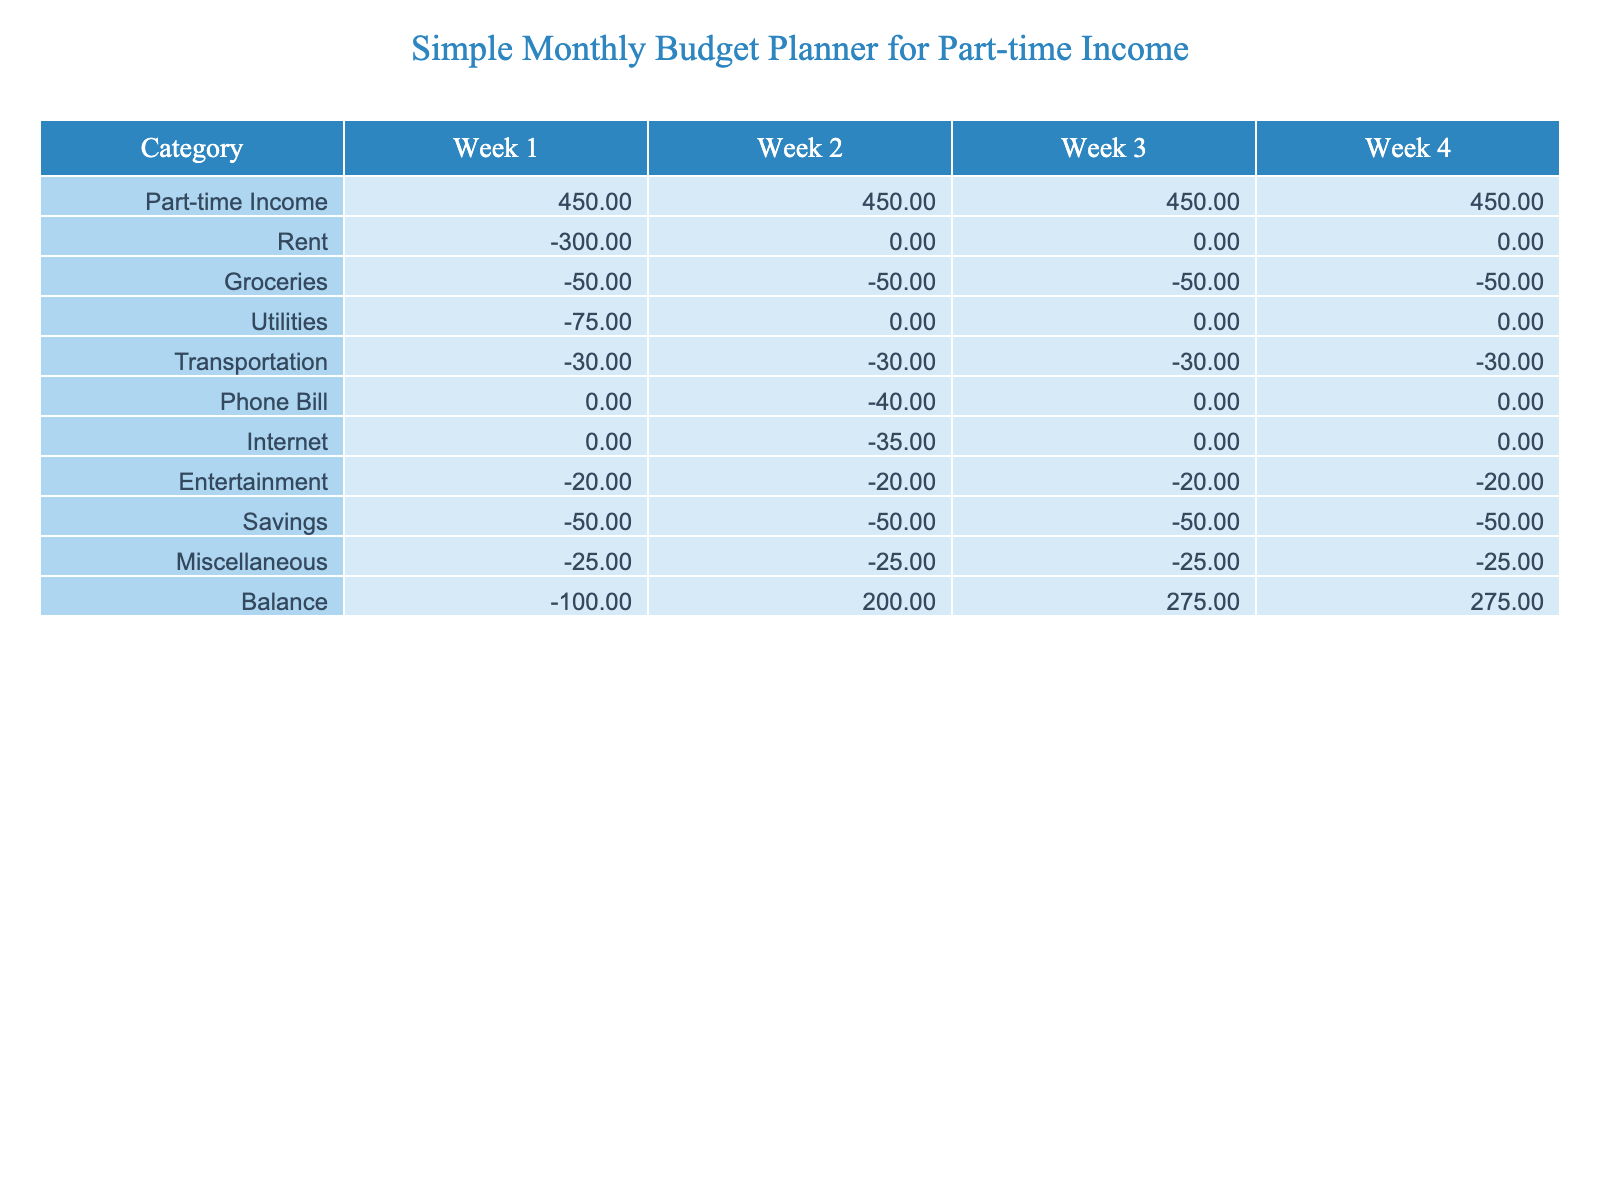What is the total part-time income for the month? The part-time income is consistent at 450 each week. Therefore, for 4 weeks, the total is 450 * 4 = 1800.
Answer: 1800 What is the total amount spent on groceries in the month? Groceries cost 50 each week for 4 weeks. Thus, total groceries expense is 50 * 4 = 200.
Answer: 200 Did the phone bill incur any charges in Week 1? The phone bill for Week 1 is recorded as 0, indicating that there were no charges for that week.
Answer: No What is the balance at the end of Week 2? The balance for Week 2 is shown as 200 in the table.
Answer: 200 What was the total expenditure on utilities for the entire month? Utilities cost 75 in Week 1 and 0 in the remaining weeks. Thus, total expenditure on utilities is 75 + 0 + 0 + 0 = 75.
Answer: 75 What is the difference between the balance at the end of Week 1 and Week 4? The balance at the end of Week 1 is -100 and at the end of Week 4 is 275. The difference is 275 - (-100) = 275 + 100 = 375.
Answer: 375 How much did the total savings for the month amount to? Savings are recorded as 50 each week for 4 weeks. Therefore, total savings is 50 * 4 = 200.
Answer: 200 In which week did the expenses for transportation remain constant? Transportation expenses are consistently -30 in Weeks 1, 2, and 3, indicating they stayed the same during those weeks.
Answer: Weeks 1, 2, and 3 What is the combined total of entertainment and miscellaneous expenses for the month? Entertainment expenses total -20 each week for 4 weeks (total -80) and miscellaneous expenses total -25 each week for 4 weeks (total -100). Combined total is -80 + -100 = -180.
Answer: -180 Which week had the highest balance, and what was that balance? The highest balance was in Week 4 at 275.
Answer: Week 4, 275 